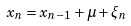<formula> <loc_0><loc_0><loc_500><loc_500>x _ { n } = x _ { n - 1 } + \mu + \xi _ { n }</formula> 